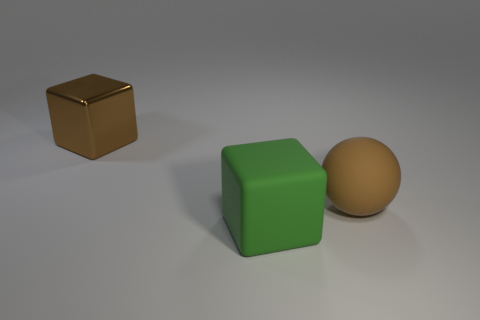How many objects are brown matte things or big green things?
Give a very brief answer. 2. The brown thing in front of the big cube behind the green rubber object is made of what material?
Provide a succinct answer. Rubber. Are there any large brown balls that have the same material as the green object?
Provide a succinct answer. Yes. What shape is the big matte thing behind the big block that is in front of the object that is behind the large brown ball?
Provide a short and direct response. Sphere. What is the material of the brown block?
Offer a terse response. Metal. The big thing that is made of the same material as the brown sphere is what color?
Your response must be concise. Green. Is there a green thing that is to the right of the cube that is in front of the brown block?
Provide a short and direct response. No. How many other objects are there of the same shape as the big brown matte thing?
Provide a short and direct response. 0. There is a brown object to the right of the metallic cube; does it have the same shape as the large object that is in front of the brown rubber sphere?
Offer a terse response. No. What number of green rubber things are right of the brown thing that is behind the big brown object that is in front of the large brown metal cube?
Your answer should be compact. 1. 